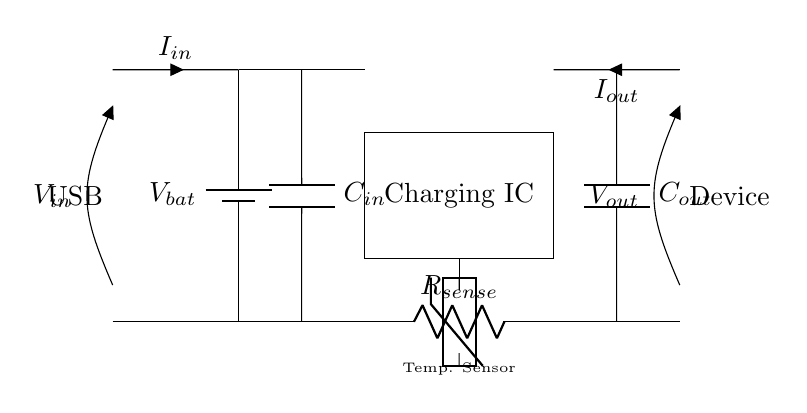What is the input voltage for this circuit? The input voltage is represented as V_in in the circuit diagram and is connected to the USB input, indicating it is typically around 5 volts for standard USB devices.
Answer: 5 volts What type of components are C_in and C_out? Both C_in and C_out are capacitors, as indicated by the symbol C in the circuit diagram. They are used to stabilize the input and output voltages.
Answer: Capacitors Which component is responsible for current sensing? The component responsible for current sensing is R_sense, indicated by the symbol R between the charging IC and the output. It helps in monitoring the flow of current in the circuit.
Answer: R_sense What role does the Charging IC play in this circuit? The Charging IC regulates the flow of current from the input to the output, ensuring that the battery charges correctly and protects against overcharging.
Answer: Regulates charging How does the temperature sensor contribute to the charging process? The temperature sensor monitors the battery's temperature; if it detects overheating, the IC can reduce or halt charging to prevent damage, ensuring safety during the operation.
Answer: Monitors battery temperature What is the output voltage when charging a device? The output voltage is represented as V_out in the circuit, which is intended to match the voltage needed by mobile devices, typically around 5 volts.
Answer: 5 volts What would happen if the C_out capacitor failed? If the C_out capacitor failed, the output voltage would become unstable, which could lead to inadequate charging of the mobile device or even cause damage to the device due to voltage spikes.
Answer: Unstable output voltage 